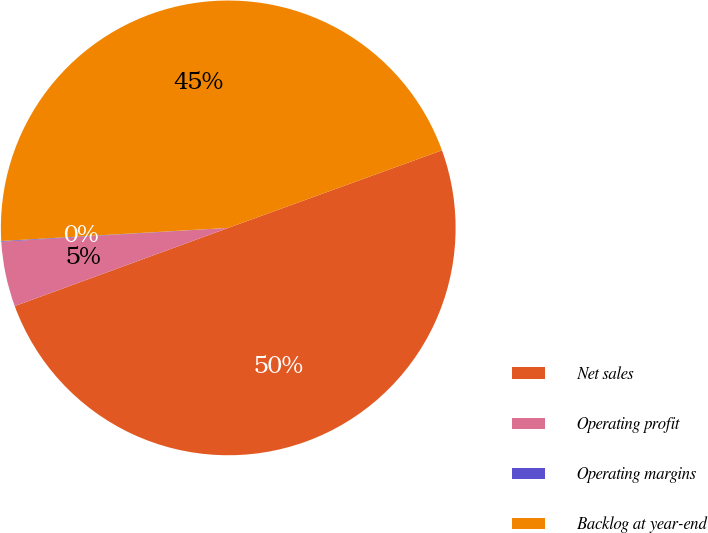Convert chart to OTSL. <chart><loc_0><loc_0><loc_500><loc_500><pie_chart><fcel>Net sales<fcel>Operating profit<fcel>Operating margins<fcel>Backlog at year-end<nl><fcel>49.95%<fcel>4.62%<fcel>0.05%<fcel>45.38%<nl></chart> 